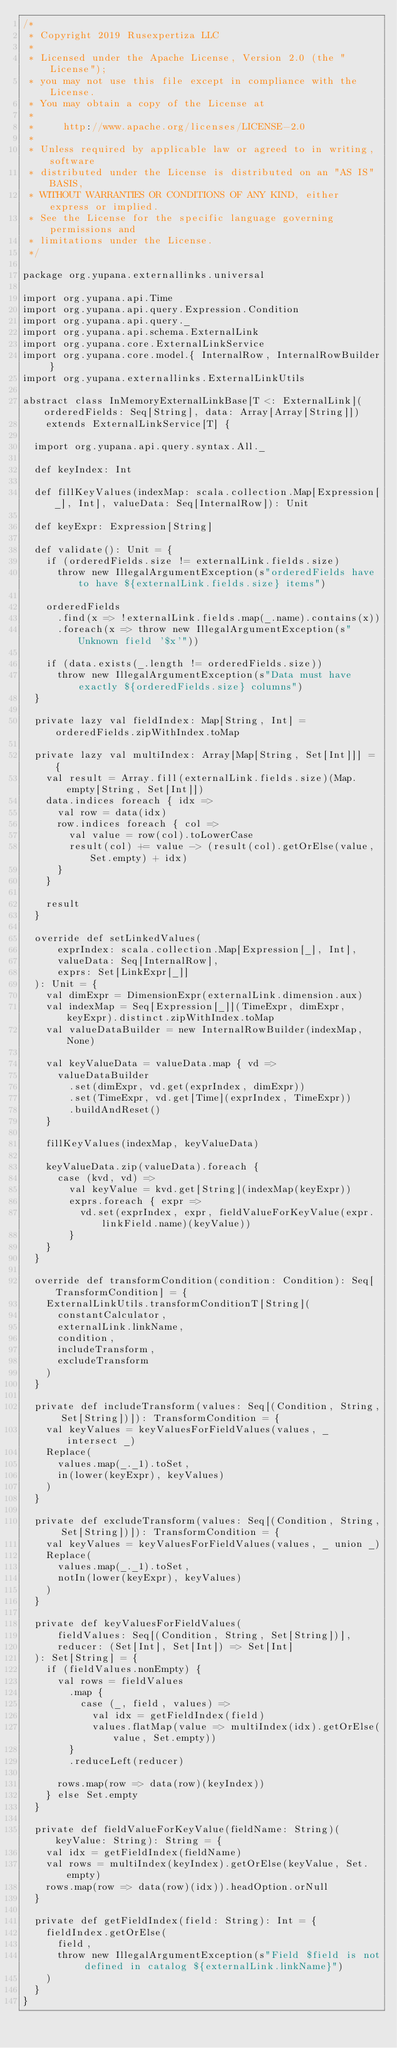<code> <loc_0><loc_0><loc_500><loc_500><_Scala_>/*
 * Copyright 2019 Rusexpertiza LLC
 *
 * Licensed under the Apache License, Version 2.0 (the "License");
 * you may not use this file except in compliance with the License.
 * You may obtain a copy of the License at
 *
 *     http://www.apache.org/licenses/LICENSE-2.0
 *
 * Unless required by applicable law or agreed to in writing, software
 * distributed under the License is distributed on an "AS IS" BASIS,
 * WITHOUT WARRANTIES OR CONDITIONS OF ANY KIND, either express or implied.
 * See the License for the specific language governing permissions and
 * limitations under the License.
 */

package org.yupana.externallinks.universal

import org.yupana.api.Time
import org.yupana.api.query.Expression.Condition
import org.yupana.api.query._
import org.yupana.api.schema.ExternalLink
import org.yupana.core.ExternalLinkService
import org.yupana.core.model.{ InternalRow, InternalRowBuilder }
import org.yupana.externallinks.ExternalLinkUtils

abstract class InMemoryExternalLinkBase[T <: ExternalLink](orderedFields: Seq[String], data: Array[Array[String]])
    extends ExternalLinkService[T] {

  import org.yupana.api.query.syntax.All._

  def keyIndex: Int

  def fillKeyValues(indexMap: scala.collection.Map[Expression[_], Int], valueData: Seq[InternalRow]): Unit

  def keyExpr: Expression[String]

  def validate(): Unit = {
    if (orderedFields.size != externalLink.fields.size)
      throw new IllegalArgumentException(s"orderedFields have to have ${externalLink.fields.size} items")

    orderedFields
      .find(x => !externalLink.fields.map(_.name).contains(x))
      .foreach(x => throw new IllegalArgumentException(s"Unknown field '$x'"))

    if (data.exists(_.length != orderedFields.size))
      throw new IllegalArgumentException(s"Data must have exactly ${orderedFields.size} columns")
  }

  private lazy val fieldIndex: Map[String, Int] = orderedFields.zipWithIndex.toMap

  private lazy val multiIndex: Array[Map[String, Set[Int]]] = {
    val result = Array.fill(externalLink.fields.size)(Map.empty[String, Set[Int]])
    data.indices foreach { idx =>
      val row = data(idx)
      row.indices foreach { col =>
        val value = row(col).toLowerCase
        result(col) += value -> (result(col).getOrElse(value, Set.empty) + idx)
      }
    }

    result
  }

  override def setLinkedValues(
      exprIndex: scala.collection.Map[Expression[_], Int],
      valueData: Seq[InternalRow],
      exprs: Set[LinkExpr[_]]
  ): Unit = {
    val dimExpr = DimensionExpr(externalLink.dimension.aux)
    val indexMap = Seq[Expression[_]](TimeExpr, dimExpr, keyExpr).distinct.zipWithIndex.toMap
    val valueDataBuilder = new InternalRowBuilder(indexMap, None)

    val keyValueData = valueData.map { vd =>
      valueDataBuilder
        .set(dimExpr, vd.get(exprIndex, dimExpr))
        .set(TimeExpr, vd.get[Time](exprIndex, TimeExpr))
        .buildAndReset()
    }

    fillKeyValues(indexMap, keyValueData)

    keyValueData.zip(valueData).foreach {
      case (kvd, vd) =>
        val keyValue = kvd.get[String](indexMap(keyExpr))
        exprs.foreach { expr =>
          vd.set(exprIndex, expr, fieldValueForKeyValue(expr.linkField.name)(keyValue))
        }
    }
  }

  override def transformCondition(condition: Condition): Seq[TransformCondition] = {
    ExternalLinkUtils.transformConditionT[String](
      constantCalculator,
      externalLink.linkName,
      condition,
      includeTransform,
      excludeTransform
    )
  }

  private def includeTransform(values: Seq[(Condition, String, Set[String])]): TransformCondition = {
    val keyValues = keyValuesForFieldValues(values, _ intersect _)
    Replace(
      values.map(_._1).toSet,
      in(lower(keyExpr), keyValues)
    )
  }

  private def excludeTransform(values: Seq[(Condition, String, Set[String])]): TransformCondition = {
    val keyValues = keyValuesForFieldValues(values, _ union _)
    Replace(
      values.map(_._1).toSet,
      notIn(lower(keyExpr), keyValues)
    )
  }

  private def keyValuesForFieldValues(
      fieldValues: Seq[(Condition, String, Set[String])],
      reducer: (Set[Int], Set[Int]) => Set[Int]
  ): Set[String] = {
    if (fieldValues.nonEmpty) {
      val rows = fieldValues
        .map {
          case (_, field, values) =>
            val idx = getFieldIndex(field)
            values.flatMap(value => multiIndex(idx).getOrElse(value, Set.empty))
        }
        .reduceLeft(reducer)

      rows.map(row => data(row)(keyIndex))
    } else Set.empty
  }

  private def fieldValueForKeyValue(fieldName: String)(keyValue: String): String = {
    val idx = getFieldIndex(fieldName)
    val rows = multiIndex(keyIndex).getOrElse(keyValue, Set.empty)
    rows.map(row => data(row)(idx)).headOption.orNull
  }

  private def getFieldIndex(field: String): Int = {
    fieldIndex.getOrElse(
      field,
      throw new IllegalArgumentException(s"Field $field is not defined in catalog ${externalLink.linkName}")
    )
  }
}
</code> 